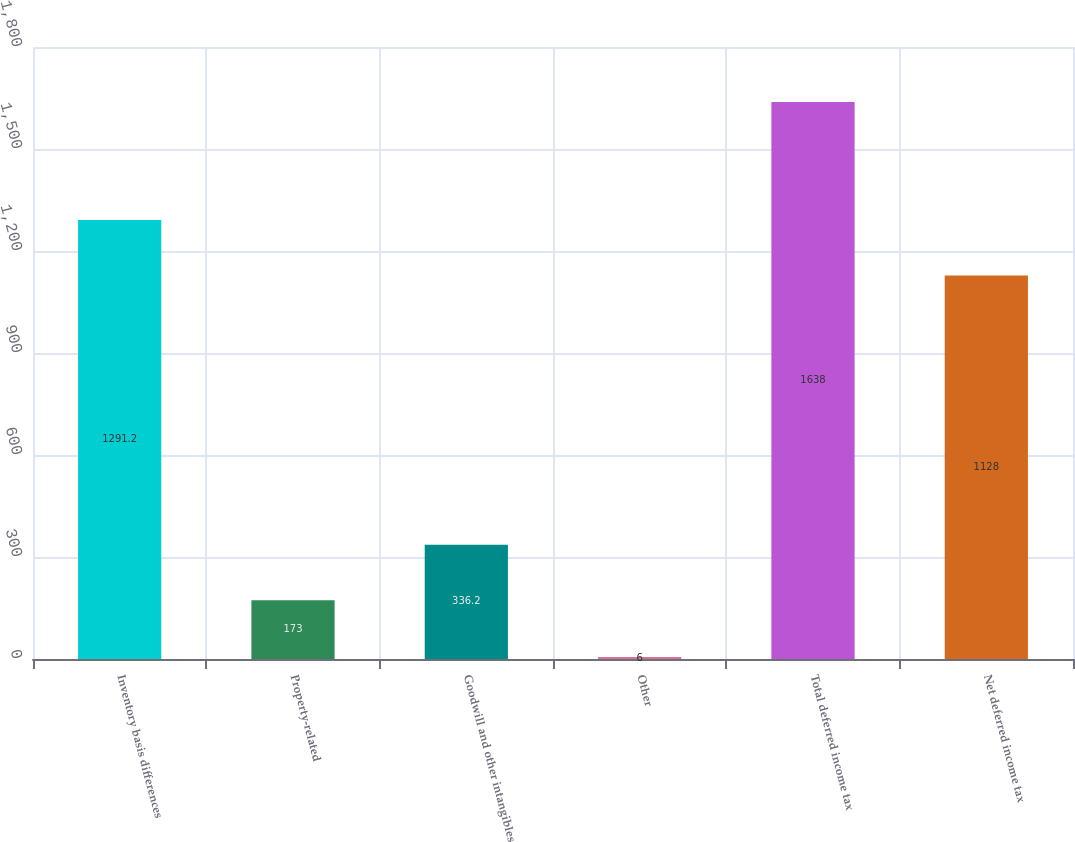<chart> <loc_0><loc_0><loc_500><loc_500><bar_chart><fcel>Inventory basis differences<fcel>Property-related<fcel>Goodwill and other intangibles<fcel>Other<fcel>Total deferred income tax<fcel>Net deferred income tax<nl><fcel>1291.2<fcel>173<fcel>336.2<fcel>6<fcel>1638<fcel>1128<nl></chart> 